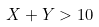<formula> <loc_0><loc_0><loc_500><loc_500>X + Y > 1 0</formula> 